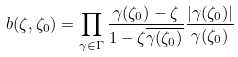Convert formula to latex. <formula><loc_0><loc_0><loc_500><loc_500>b ( \zeta , \zeta _ { 0 } ) = \prod _ { \gamma \in \Gamma } \frac { \gamma ( \zeta _ { 0 } ) - \zeta } { 1 - \zeta \overline { \gamma ( \zeta _ { 0 } ) } } \frac { | \gamma ( \zeta _ { 0 } ) | } { \gamma ( \zeta _ { 0 } ) }</formula> 